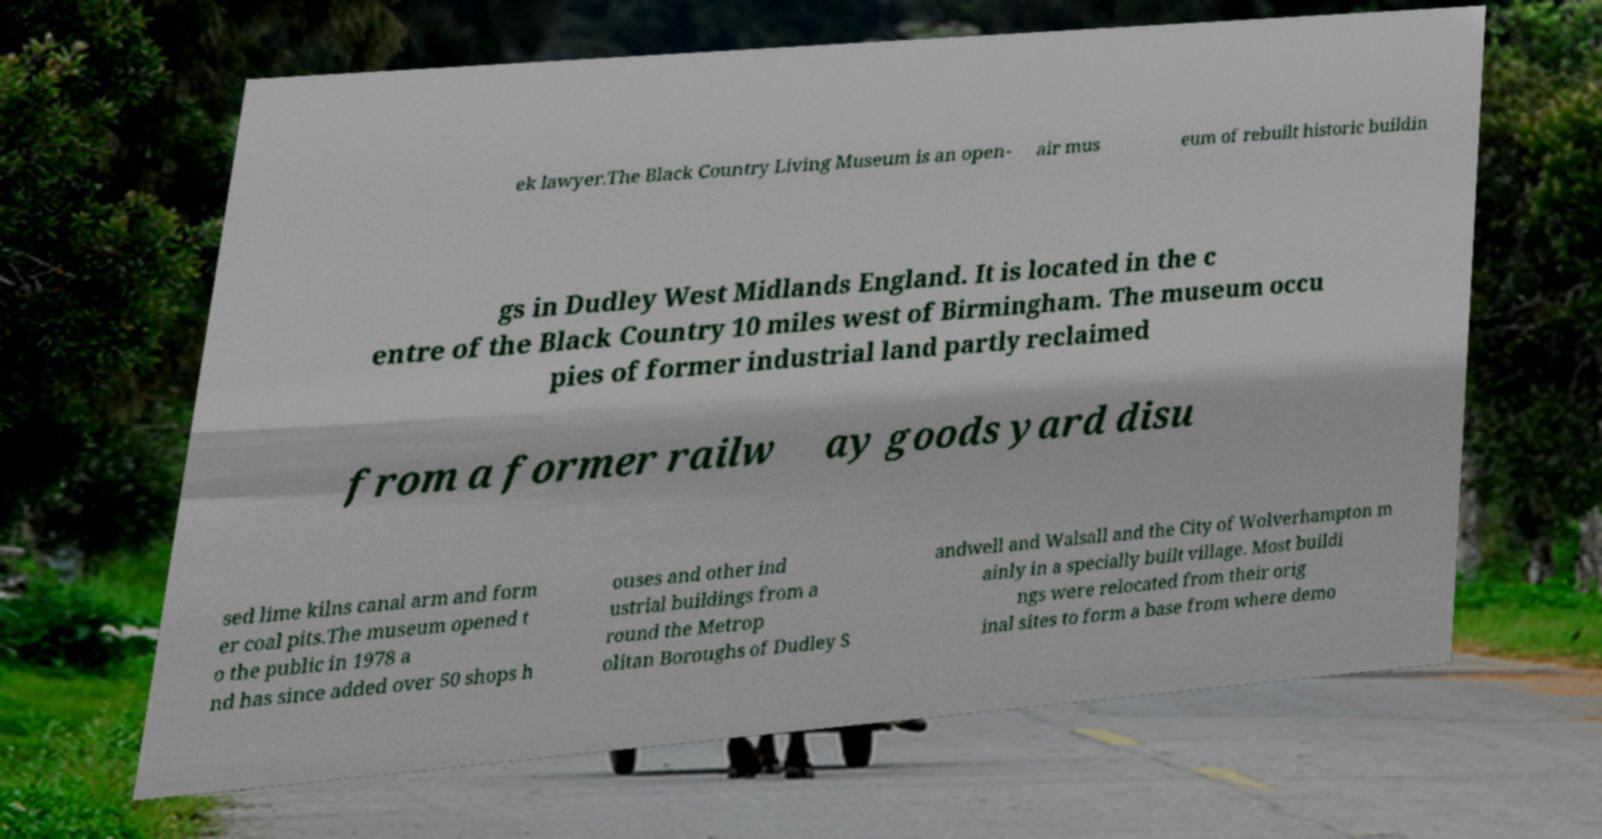Please identify and transcribe the text found in this image. ek lawyer.The Black Country Living Museum is an open- air mus eum of rebuilt historic buildin gs in Dudley West Midlands England. It is located in the c entre of the Black Country 10 miles west of Birmingham. The museum occu pies of former industrial land partly reclaimed from a former railw ay goods yard disu sed lime kilns canal arm and form er coal pits.The museum opened t o the public in 1978 a nd has since added over 50 shops h ouses and other ind ustrial buildings from a round the Metrop olitan Boroughs of Dudley S andwell and Walsall and the City of Wolverhampton m ainly in a specially built village. Most buildi ngs were relocated from their orig inal sites to form a base from where demo 